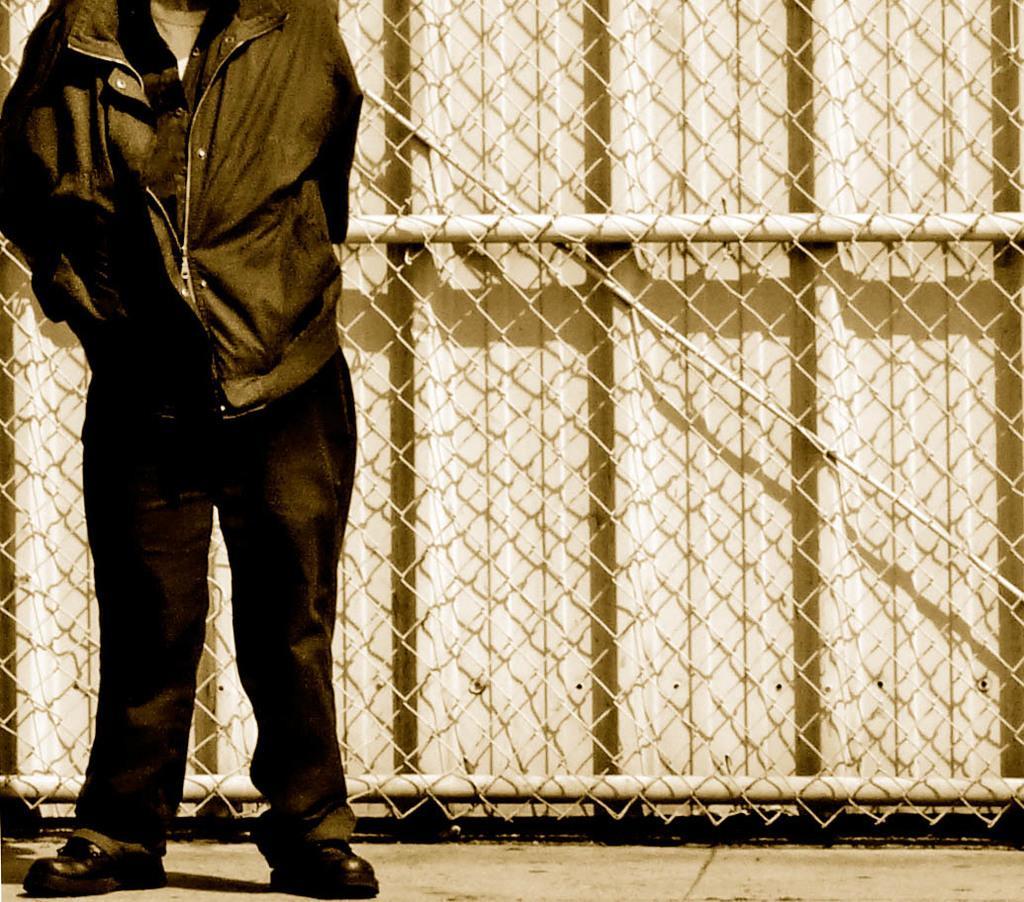In one or two sentences, can you explain what this image depicts? In this image, we can see a person who´s face is not visible standing in front of the fencing. 